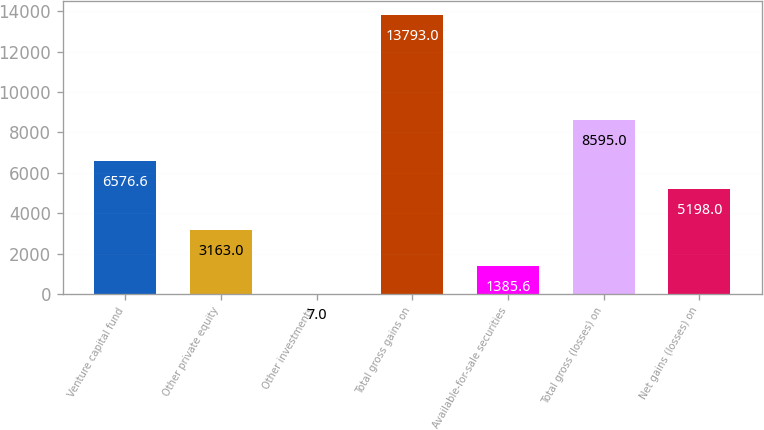Convert chart. <chart><loc_0><loc_0><loc_500><loc_500><bar_chart><fcel>Venture capital fund<fcel>Other private equity<fcel>Other investments<fcel>Total gross gains on<fcel>Available-for-sale securities<fcel>Total gross (losses) on<fcel>Net gains (losses) on<nl><fcel>6576.6<fcel>3163<fcel>7<fcel>13793<fcel>1385.6<fcel>8595<fcel>5198<nl></chart> 